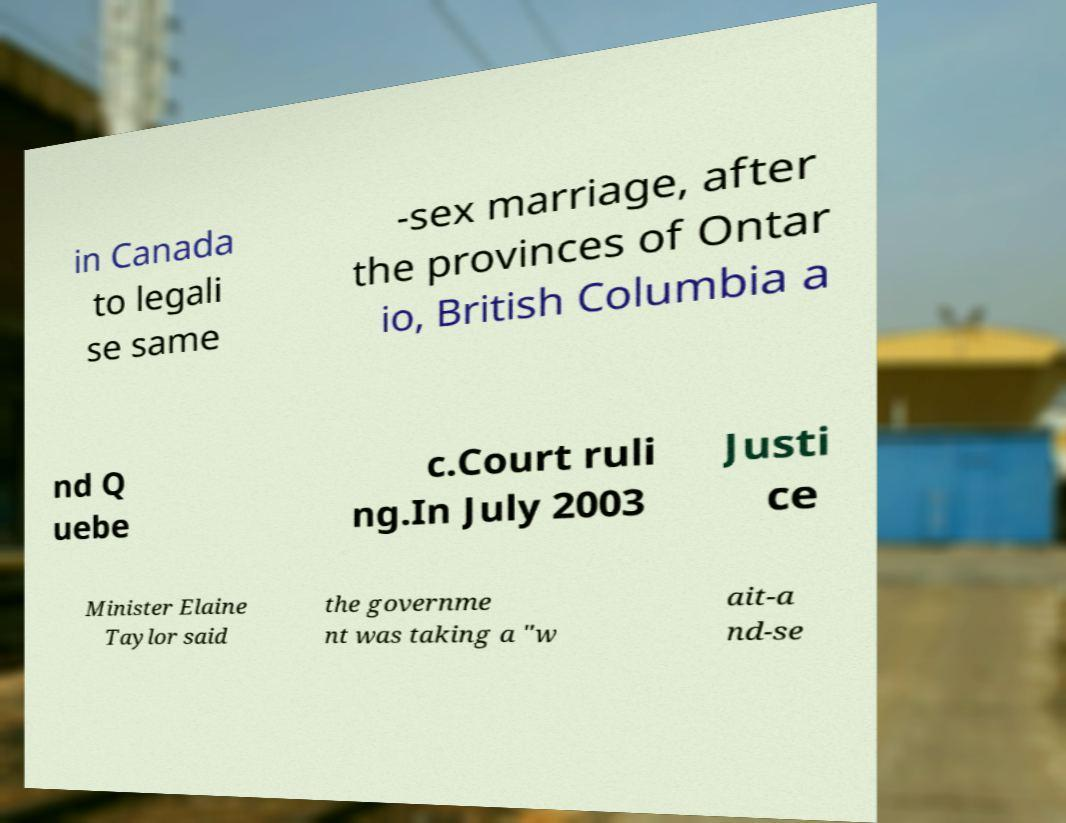Can you read and provide the text displayed in the image?This photo seems to have some interesting text. Can you extract and type it out for me? in Canada to legali se same -sex marriage, after the provinces of Ontar io, British Columbia a nd Q uebe c.Court ruli ng.In July 2003 Justi ce Minister Elaine Taylor said the governme nt was taking a "w ait-a nd-se 